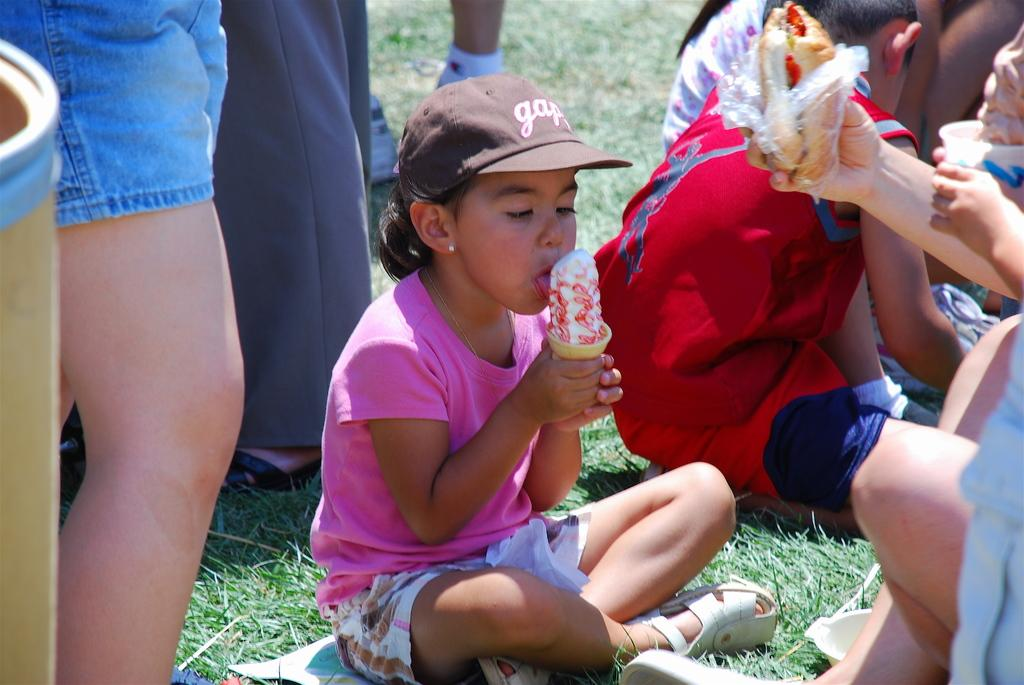<image>
Offer a succinct explanation of the picture presented. A young girl in a brown gap hat licks an ice cream cone. 